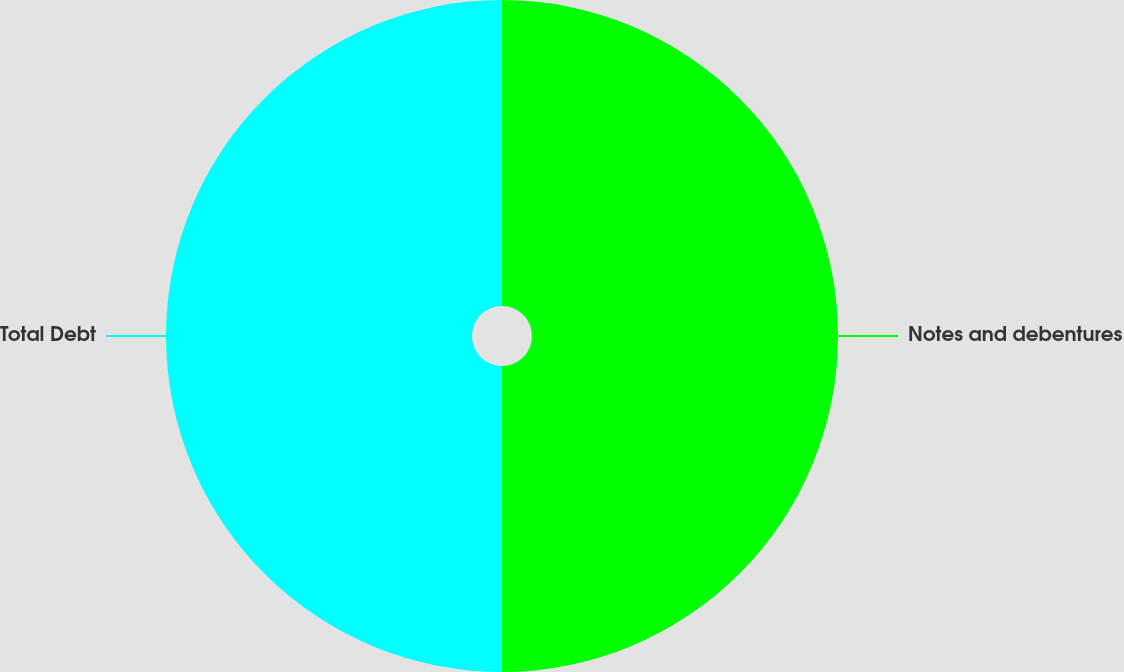<chart> <loc_0><loc_0><loc_500><loc_500><pie_chart><fcel>Notes and debentures<fcel>Total Debt<nl><fcel>50.0%<fcel>50.0%<nl></chart> 